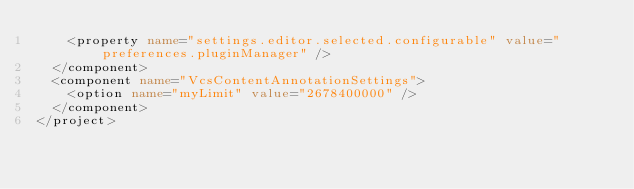Convert code to text. <code><loc_0><loc_0><loc_500><loc_500><_XML_>    <property name="settings.editor.selected.configurable" value="preferences.pluginManager" />
  </component>
  <component name="VcsContentAnnotationSettings">
    <option name="myLimit" value="2678400000" />
  </component>
</project></code> 